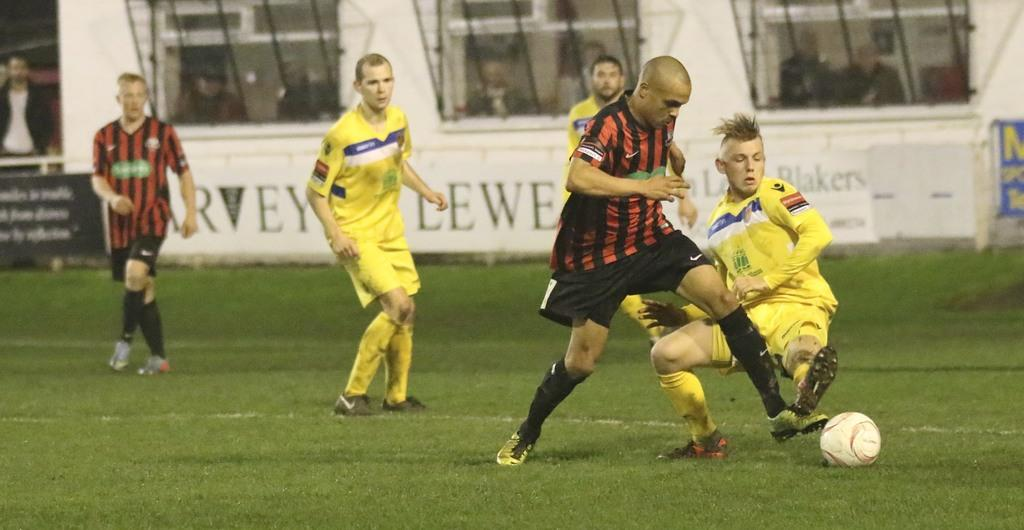What type of location is shown in the image? The image depicts a playground. What activity are the men engaged in? The men are playing football in the image. What can be seen in the background of the image? There are hoardings visible in the background. Are there any other people present in the image besides the men playing football? Yes, there are persons standing in the background. What type of record is being set by the person reading a book in the image? There is no person reading a book in the image; it depicts men playing football and people standing in the background. What type of care is being provided to the person walking their dog in the image? There is no person walking a dog in the image; it depicts a playground with men playing football and people standing in the background. 